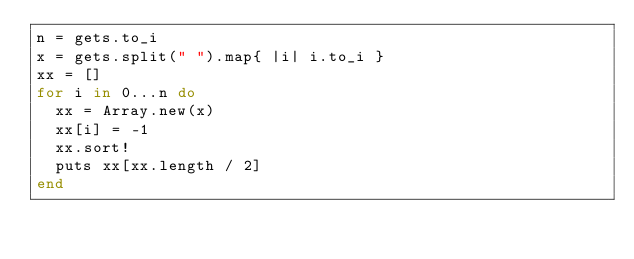<code> <loc_0><loc_0><loc_500><loc_500><_Ruby_>n = gets.to_i
x = gets.split(" ").map{ |i| i.to_i }
xx = []
for i in 0...n do
  xx = Array.new(x)
  xx[i] = -1
  xx.sort!
  puts xx[xx.length / 2]
end
</code> 